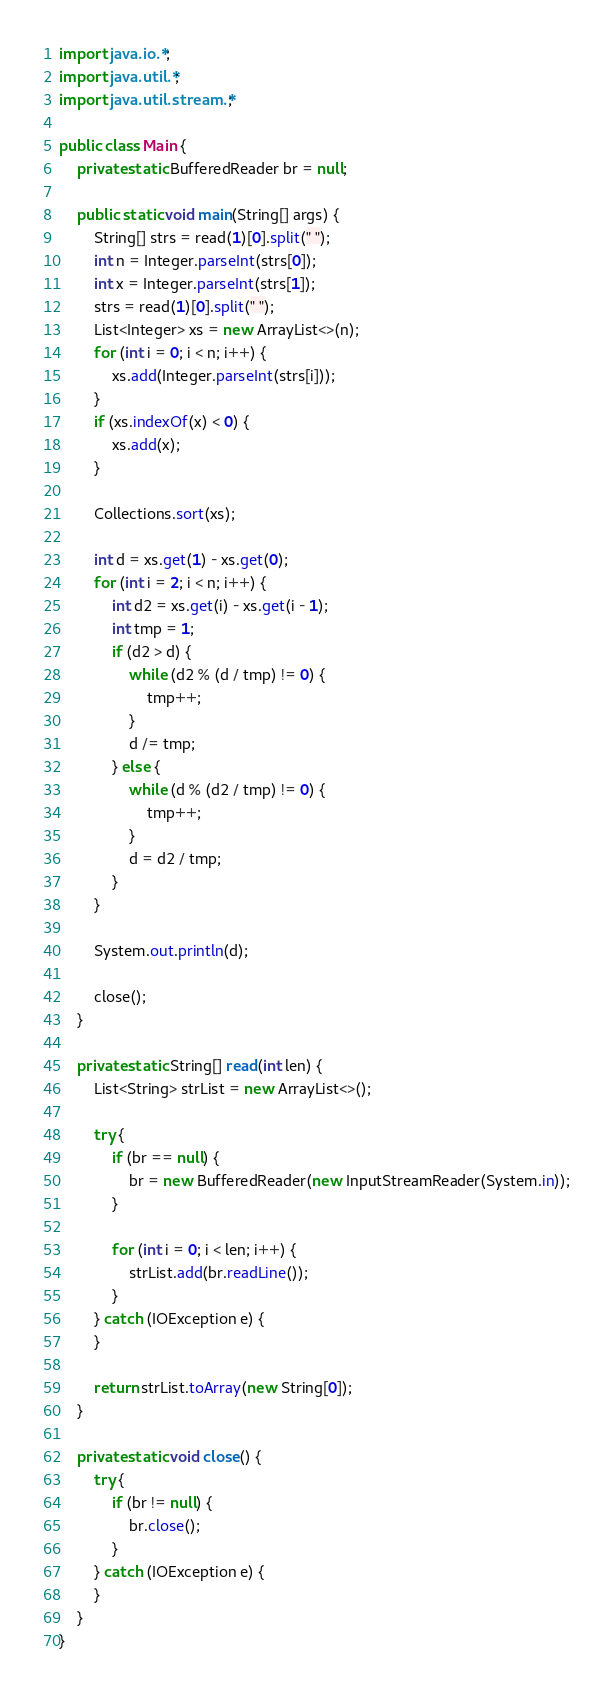Convert code to text. <code><loc_0><loc_0><loc_500><loc_500><_Java_>import java.io.*;
import java.util.*;
import java.util.stream.*;

public class Main {
	private static BufferedReader br = null;
	
	public static void main(String[] args) {
		String[] strs = read(1)[0].split(" ");
		int n = Integer.parseInt(strs[0]);
		int x = Integer.parseInt(strs[1]);
		strs = read(1)[0].split(" ");
		List<Integer> xs = new ArrayList<>(n);
		for (int i = 0; i < n; i++) {
			xs.add(Integer.parseInt(strs[i]));
		}
		if (xs.indexOf(x) < 0) {
			xs.add(x);
		}
		
		Collections.sort(xs);
		
		int d = xs.get(1) - xs.get(0);
		for (int i = 2; i < n; i++) {
			int d2 = xs.get(i) - xs.get(i - 1);
			int tmp = 1;
			if (d2 > d) {
				while (d2 % (d / tmp) != 0) {
					tmp++;
				}
				d /= tmp;
			} else {
				while (d % (d2 / tmp) != 0) {
					tmp++;
				}
				d = d2 / tmp;
			}
		}
		
		System.out.println(d);
		
		close();
	}
	
	private static String[] read(int len) {
		List<String> strList = new ArrayList<>();
		
		try {
			if (br == null) {
				br = new BufferedReader(new InputStreamReader(System.in));
			}
			
			for (int i = 0; i < len; i++) {
				strList.add(br.readLine());
			}
		} catch (IOException e) {
		}
		
		return strList.toArray(new String[0]);
	}
	
	private static void close() {
		try {
			if (br != null) {
				br.close();
			}
		} catch (IOException e) {
		}
	}
}
</code> 